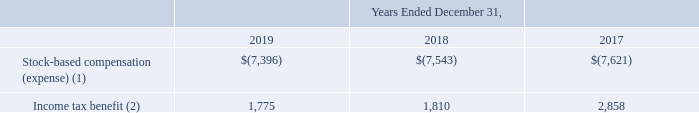Note 24. Stock-Based Compensation
The Company’s stock-based compensation plans include the 2019 Equity Incentive Plan for employees and certain non-employees, including non-employee directors, and the Deferred Compensation Plan for certain eligible employees. The Company issues common stock and uses treasury stock to satisfy stock option exercises or vesting of stock awards.
The following table summarizes the stock-based compensation expense (primarily in the Americas) and income tax benefits related to the stock-based compensation, both plan and non-plan related (in thousands):
(1) Included in "General and administrative" costs in the accompanying Consolidated Statements of Operations.
(2) Included in "Income taxes" in the accompanying Consolidated Statements of Operations.
There were no capitalized stock-based compensation costs as of December 31, 2019, 2018 and 2017.
Where is stock-based compensation (expense) included? In "general and administrative" costs in the accompanying consolidated statements of operations. Where is Income tax benefit included? In "income taxes" in the accompanying consolidated statements of operations. In which years is income tax benefit calculated? 2019, 2018, 2017. In which year was the income tax benefit smallest? 1,775<1,810<2,858
Answer: 2019. What was the change in income tax benefit in 2019 from 2018?
Answer scale should be: thousand. 1,775-1,810
Answer: -35. What was the percentage change in income tax benefit in 2019 from 2018?
Answer scale should be: percent. (1,775-1,810)/1,810
Answer: -1.93. 